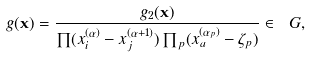Convert formula to latex. <formula><loc_0><loc_0><loc_500><loc_500>g ( \mathbf x ) = \frac { { g } _ { 2 } ( \mathbf x ) } { \prod ( x _ { i } ^ { ( \alpha ) } - x _ { j } ^ { ( \alpha + 1 ) } ) \prod _ { p } ( x _ { a } ^ { ( \alpha _ { p } ) } - \zeta _ { p } ) } \in \ G ,</formula> 